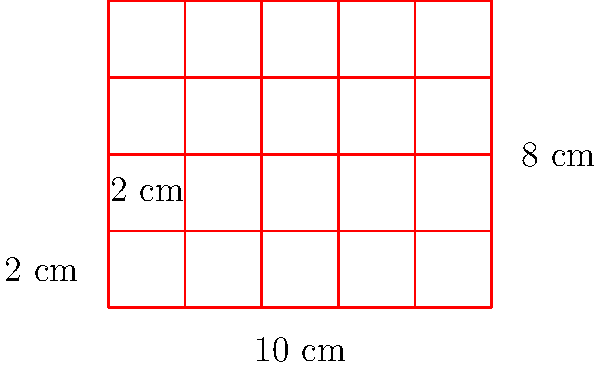You have a rectangular baking tray that measures 10 cm by 8 cm. If you want to make square cookies that are 2 cm on each side, how many cookies can you fit on the tray without overlapping? To solve this problem, we need to follow these steps:

1. Calculate the number of cookies that can fit along the length of the tray:
   $\text{Length of tray} \div \text{Length of cookie} = 10 \text{ cm} \div 2 \text{ cm} = 5$ cookies

2. Calculate the number of cookies that can fit along the width of the tray:
   $\text{Width of tray} \div \text{Width of cookie} = 8 \text{ cm} \div 2 \text{ cm} = 4$ cookies

3. Calculate the total number of cookies by multiplying the number that fit along the length and width:
   $5 \times 4 = 20$ cookies

Therefore, you can fit 20 square cookies on the rectangular baking tray without overlapping.
Answer: 20 cookies 